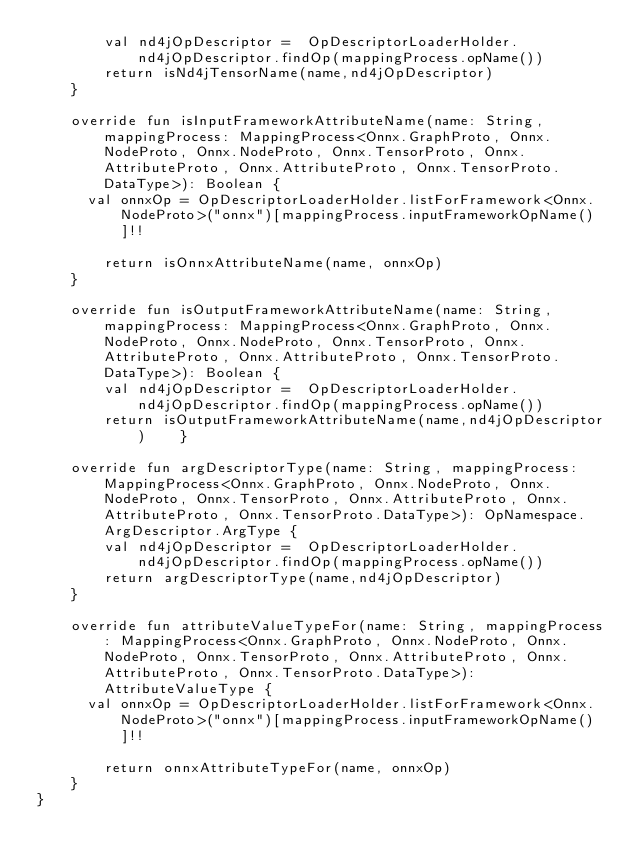<code> <loc_0><loc_0><loc_500><loc_500><_Kotlin_>        val nd4jOpDescriptor =  OpDescriptorLoaderHolder.nd4jOpDescriptor.findOp(mappingProcess.opName())
        return isNd4jTensorName(name,nd4jOpDescriptor)
    }

    override fun isInputFrameworkAttributeName(name: String, mappingProcess: MappingProcess<Onnx.GraphProto, Onnx.NodeProto, Onnx.NodeProto, Onnx.TensorProto, Onnx.AttributeProto, Onnx.AttributeProto, Onnx.TensorProto.DataType>): Boolean {
      val onnxOp = OpDescriptorLoaderHolder.listForFramework<Onnx.NodeProto>("onnx")[mappingProcess.inputFrameworkOpName()]!!

        return isOnnxAttributeName(name, onnxOp)
    }

    override fun isOutputFrameworkAttributeName(name: String, mappingProcess: MappingProcess<Onnx.GraphProto, Onnx.NodeProto, Onnx.NodeProto, Onnx.TensorProto, Onnx.AttributeProto, Onnx.AttributeProto, Onnx.TensorProto.DataType>): Boolean {
        val nd4jOpDescriptor =  OpDescriptorLoaderHolder.nd4jOpDescriptor.findOp(mappingProcess.opName())
        return isOutputFrameworkAttributeName(name,nd4jOpDescriptor)    }

    override fun argDescriptorType(name: String, mappingProcess: MappingProcess<Onnx.GraphProto, Onnx.NodeProto, Onnx.NodeProto, Onnx.TensorProto, Onnx.AttributeProto, Onnx.AttributeProto, Onnx.TensorProto.DataType>): OpNamespace.ArgDescriptor.ArgType {
        val nd4jOpDescriptor =  OpDescriptorLoaderHolder.nd4jOpDescriptor.findOp(mappingProcess.opName())
        return argDescriptorType(name,nd4jOpDescriptor)
    }

    override fun attributeValueTypeFor(name: String, mappingProcess: MappingProcess<Onnx.GraphProto, Onnx.NodeProto, Onnx.NodeProto, Onnx.TensorProto, Onnx.AttributeProto, Onnx.AttributeProto, Onnx.TensorProto.DataType>): AttributeValueType {
      val onnxOp = OpDescriptorLoaderHolder.listForFramework<Onnx.NodeProto>("onnx")[mappingProcess.inputFrameworkOpName()]!!

        return onnxAttributeTypeFor(name, onnxOp)
    }
}</code> 